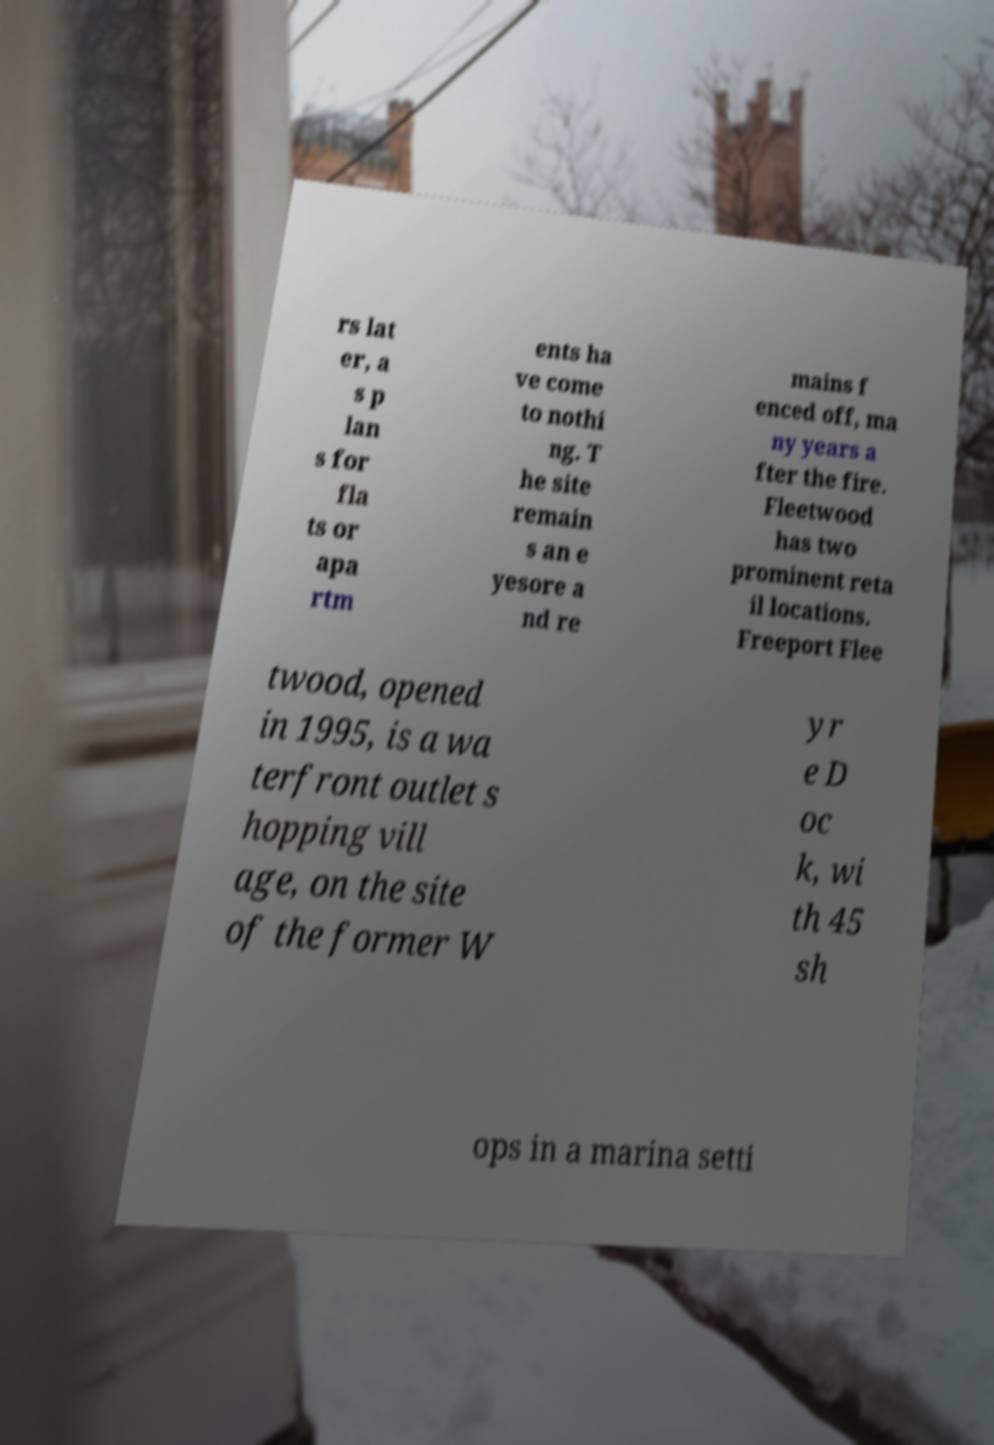There's text embedded in this image that I need extracted. Can you transcribe it verbatim? rs lat er, a s p lan s for fla ts or apa rtm ents ha ve come to nothi ng. T he site remain s an e yesore a nd re mains f enced off, ma ny years a fter the fire. Fleetwood has two prominent reta il locations. Freeport Flee twood, opened in 1995, is a wa terfront outlet s hopping vill age, on the site of the former W yr e D oc k, wi th 45 sh ops in a marina setti 